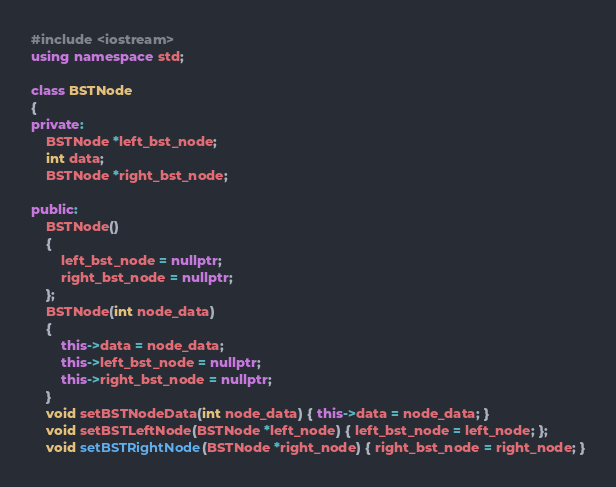<code> <loc_0><loc_0><loc_500><loc_500><_C++_>#include <iostream>
using namespace std;

class BSTNode
{
private:
    BSTNode *left_bst_node;
    int data;
    BSTNode *right_bst_node;

public:
    BSTNode()
    {
        left_bst_node = nullptr;
        right_bst_node = nullptr;
    };
    BSTNode(int node_data)
    {
        this->data = node_data;
        this->left_bst_node = nullptr;
        this->right_bst_node = nullptr;
    }
    void setBSTNodeData(int node_data) { this->data = node_data; }
    void setBSTLeftNode(BSTNode *left_node) { left_bst_node = left_node; };
    void setBSTRightNode(BSTNode *right_node) { right_bst_node = right_node; }
</code> 